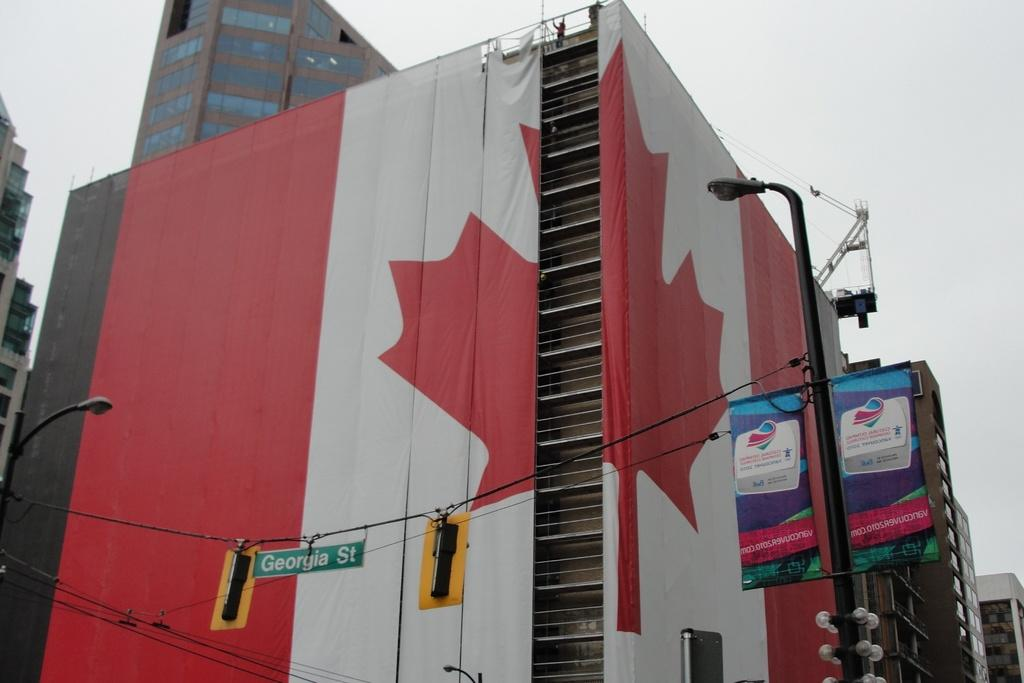<image>
Render a clear and concise summary of the photo. A huge Canadian flag banner is hung over Georgia Street. 